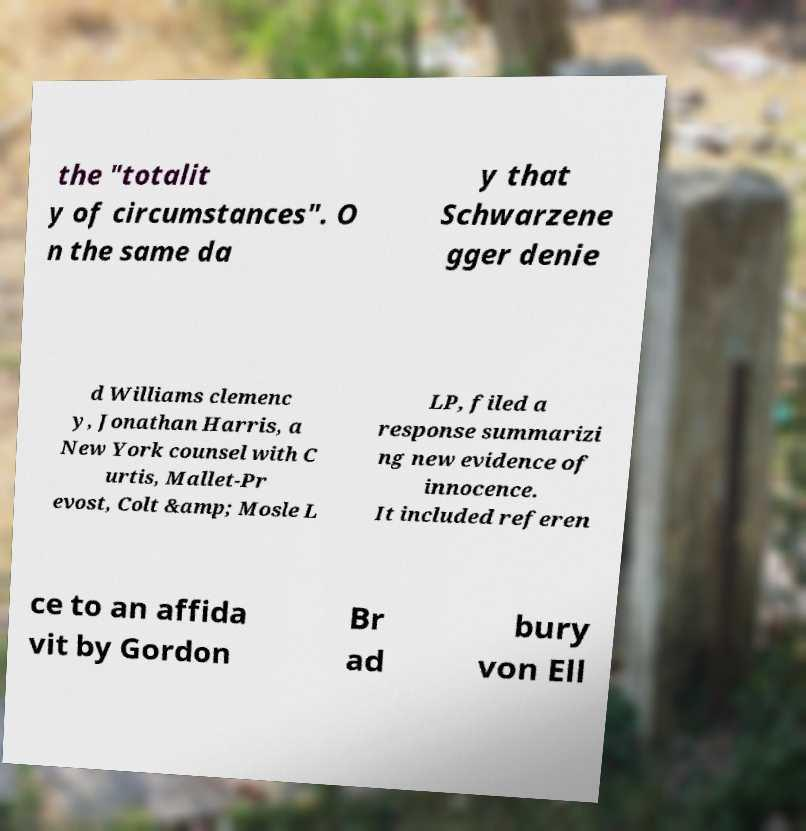Can you read and provide the text displayed in the image?This photo seems to have some interesting text. Can you extract and type it out for me? the "totalit y of circumstances". O n the same da y that Schwarzene gger denie d Williams clemenc y, Jonathan Harris, a New York counsel with C urtis, Mallet-Pr evost, Colt &amp; Mosle L LP, filed a response summarizi ng new evidence of innocence. It included referen ce to an affida vit by Gordon Br ad bury von Ell 